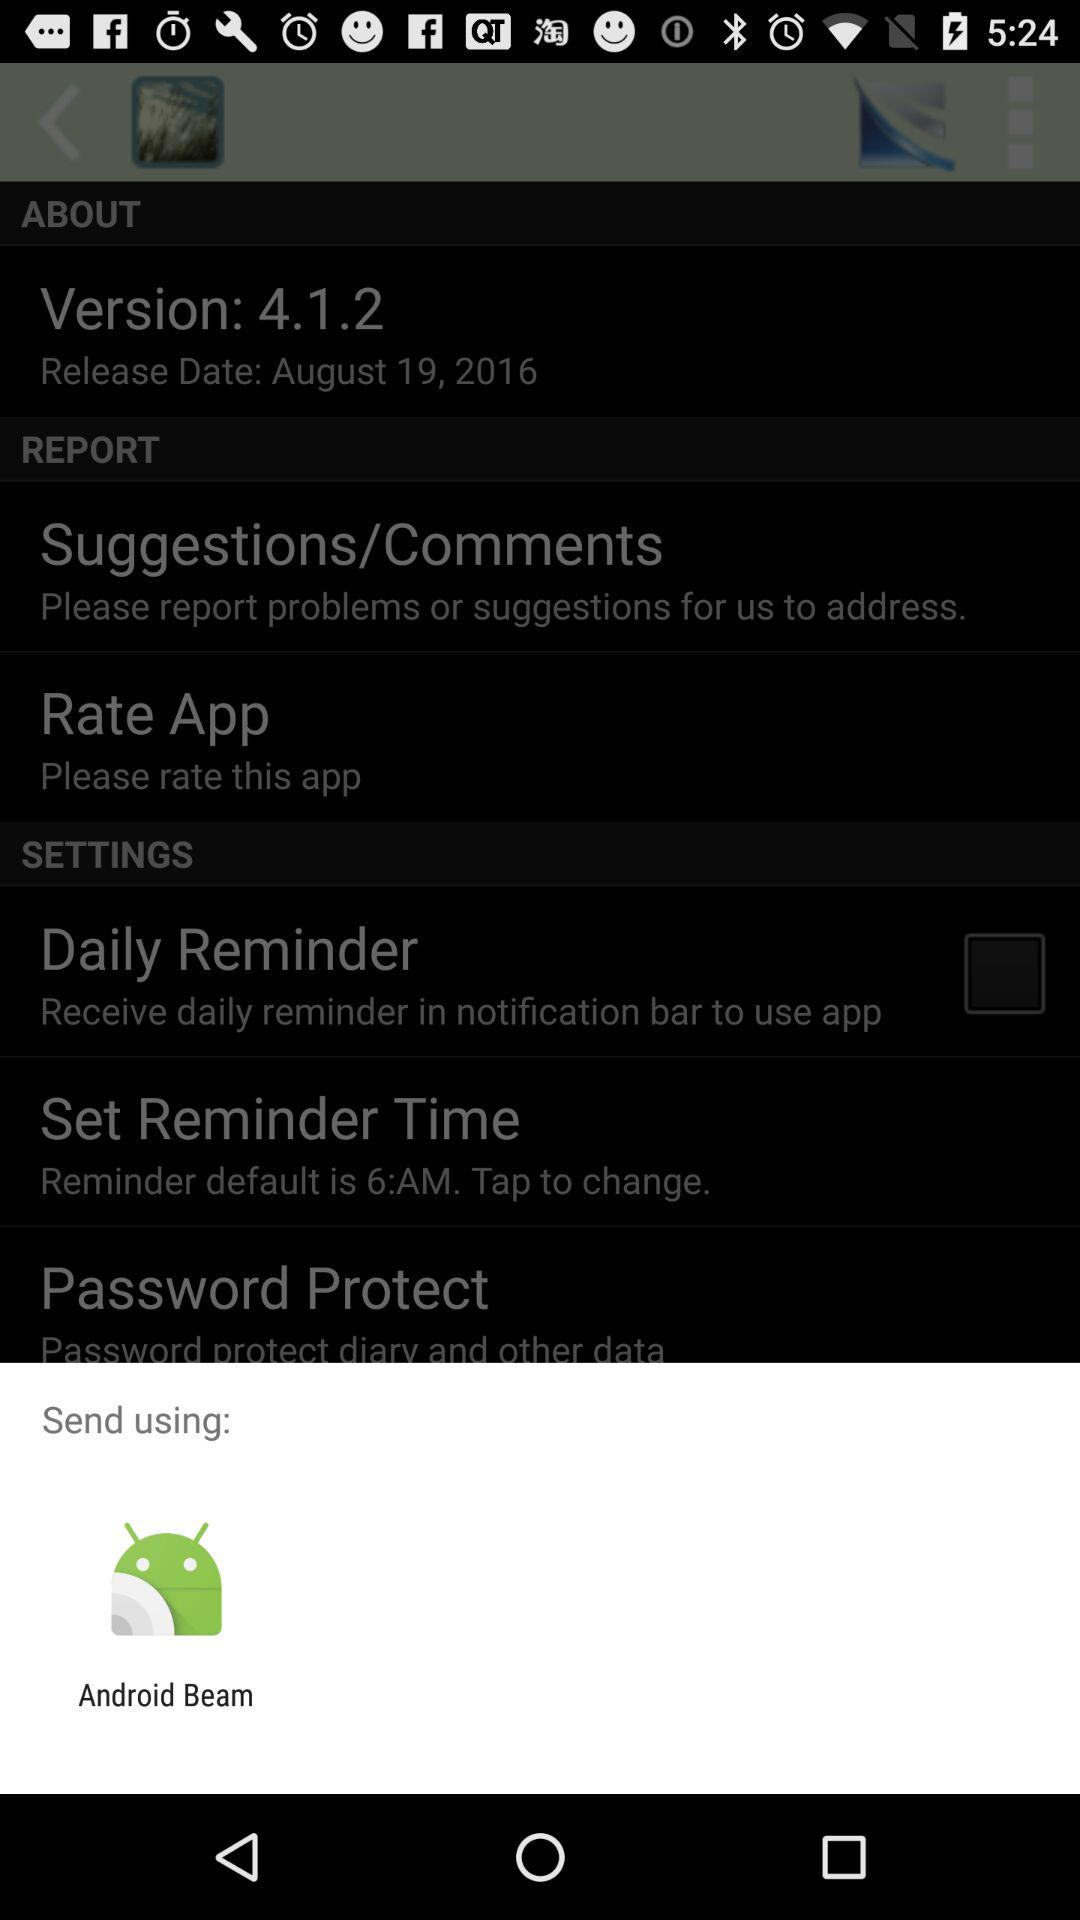What is the version? The version is 4.1.2. 